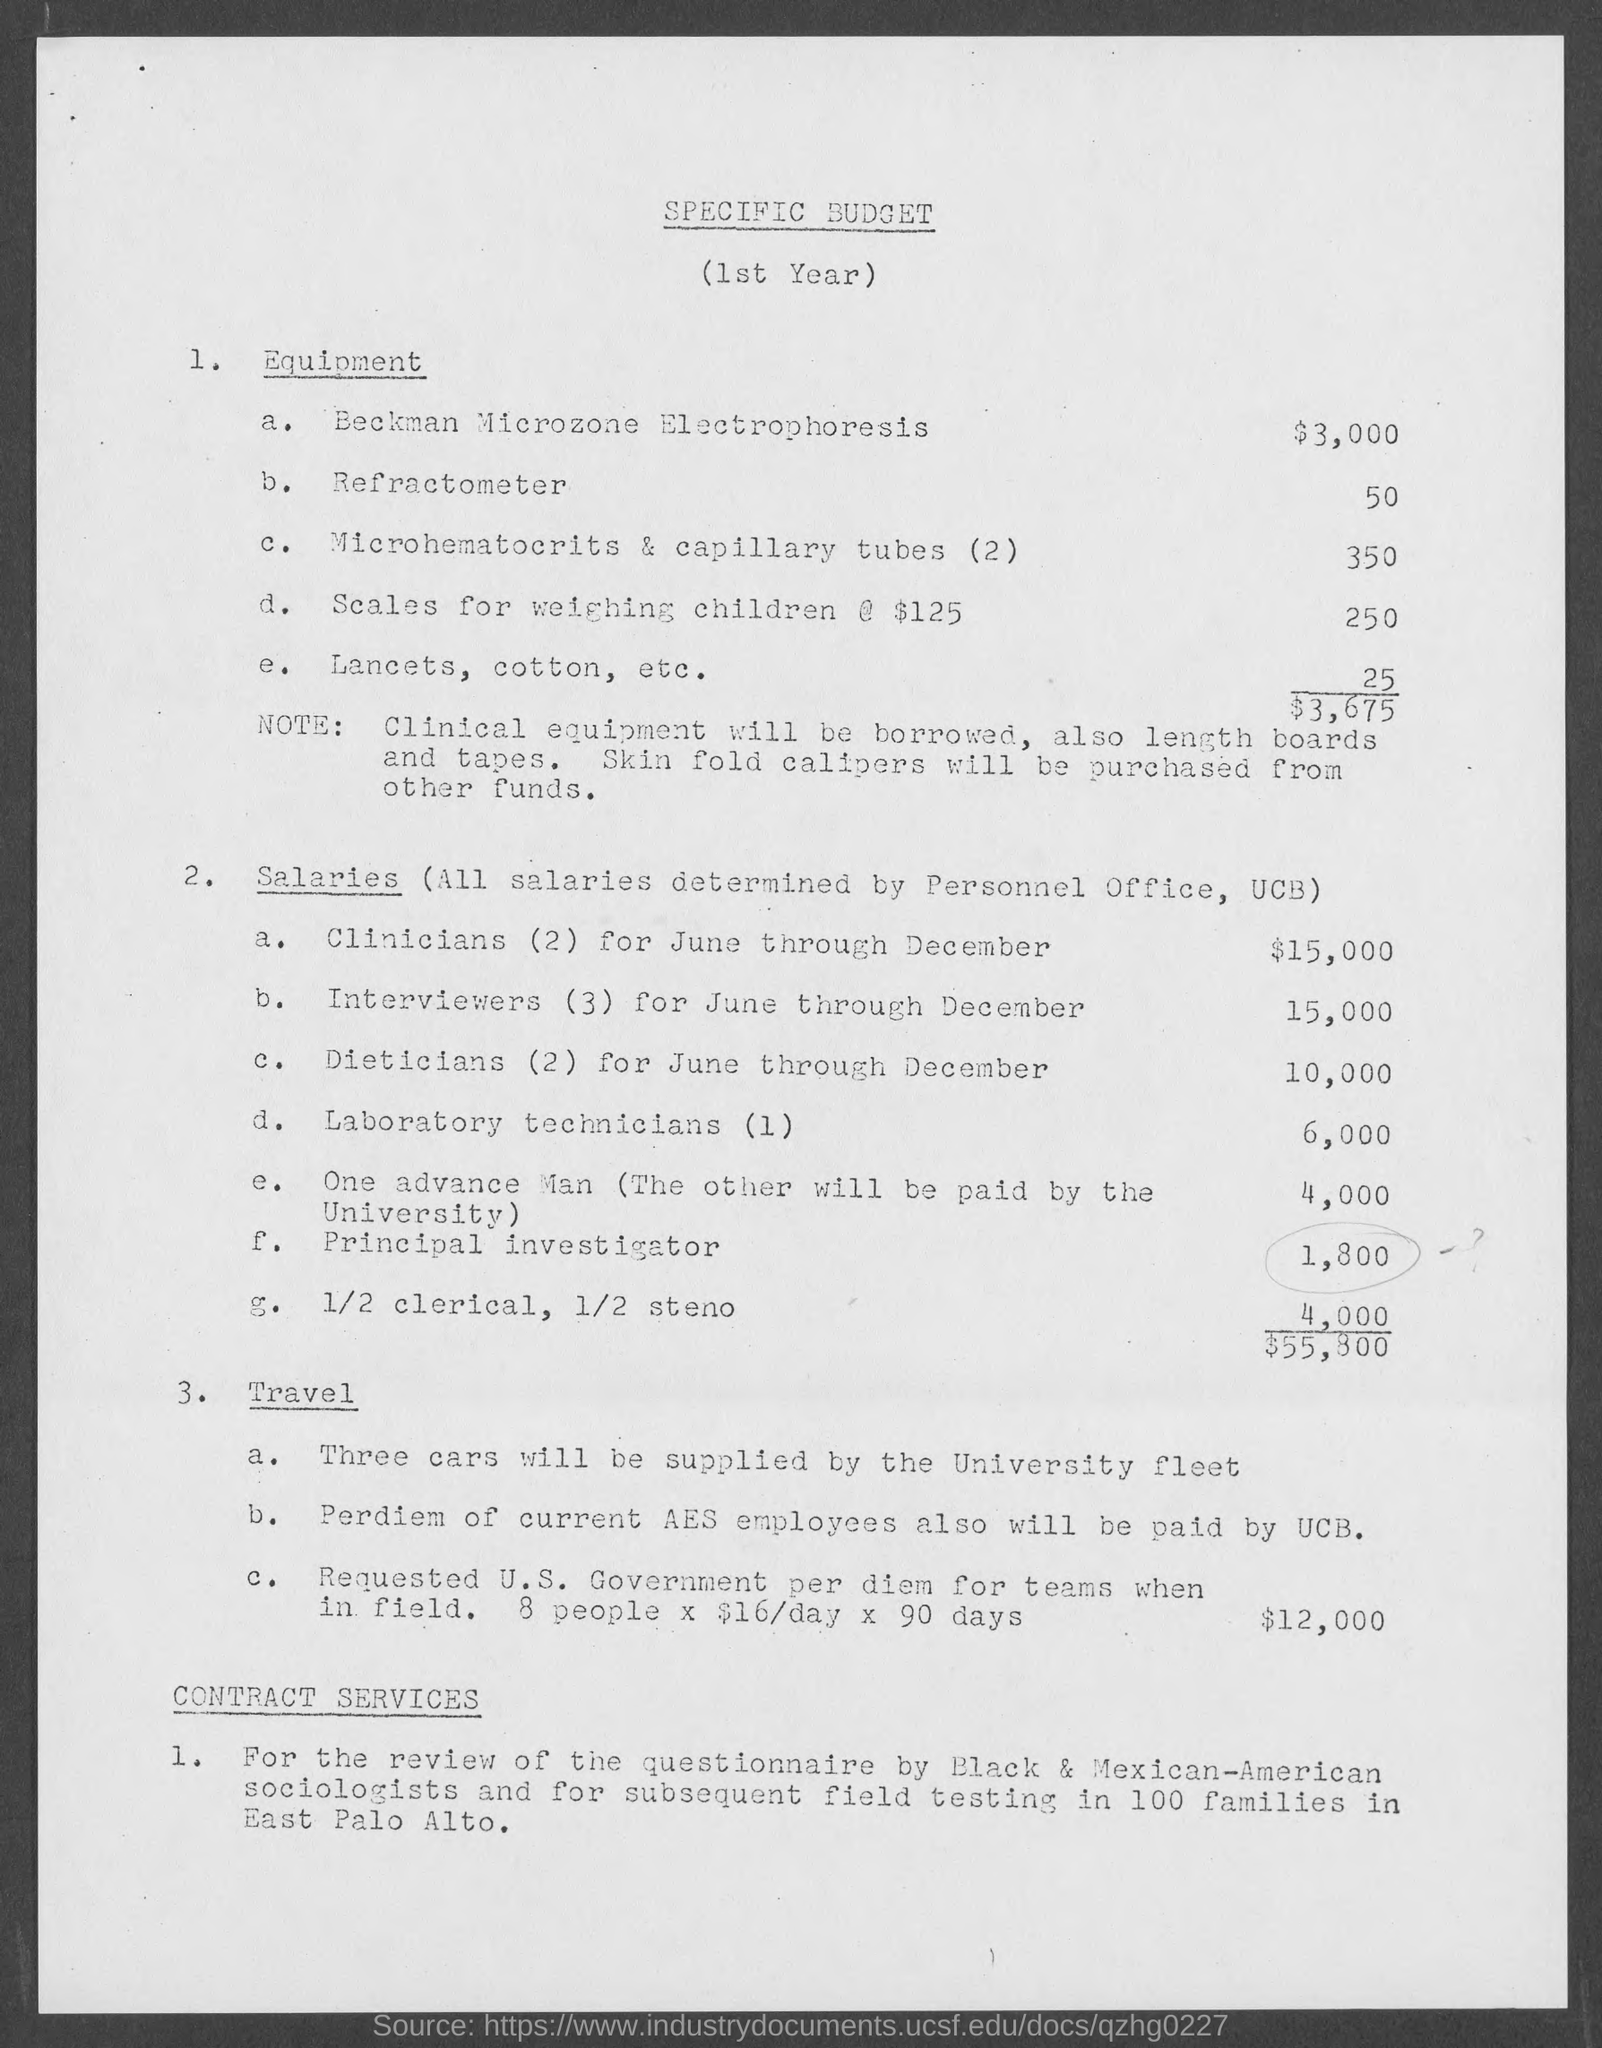What is the Cost for Beckman Microzone Electrophoresis? According to the specific budget document provided, the cost for Beckman Microzone Electrophoresis listed is $3,000, under the Equipment section for the first year. 